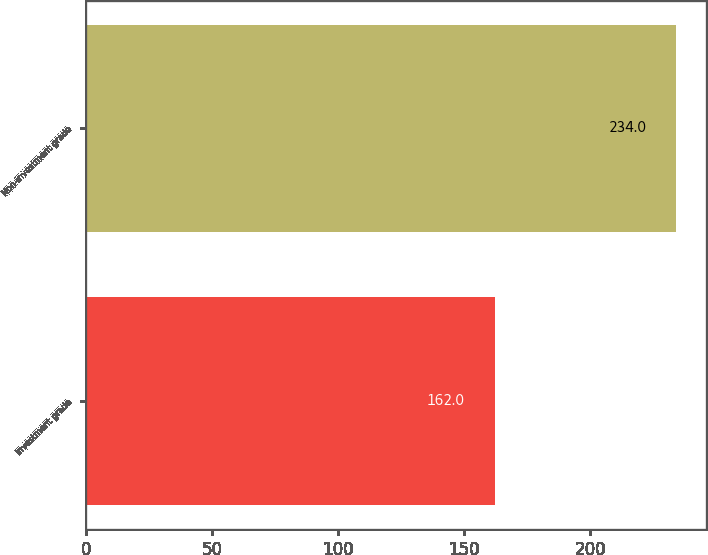<chart> <loc_0><loc_0><loc_500><loc_500><bar_chart><fcel>Investment grade<fcel>Non-investment grade<nl><fcel>162<fcel>234<nl></chart> 